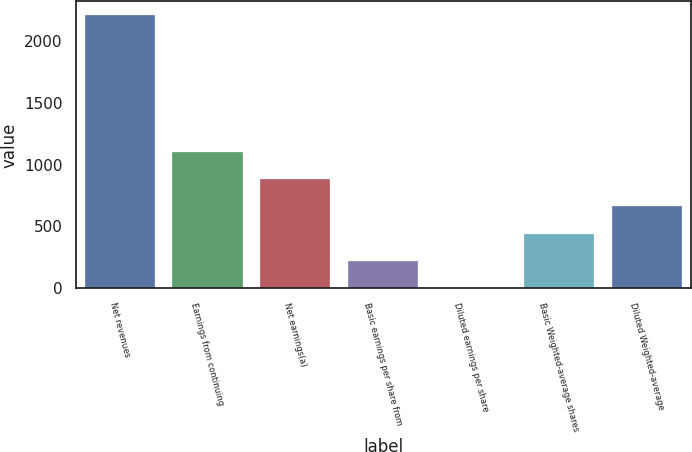Convert chart. <chart><loc_0><loc_0><loc_500><loc_500><bar_chart><fcel>Net revenues<fcel>Earnings from continuing<fcel>Net earnings(a)<fcel>Basic earnings per share from<fcel>Diluted earnings per share<fcel>Basic Weighted-average shares<fcel>Diluted Weighted-average<nl><fcel>2207.5<fcel>1104.41<fcel>883.8<fcel>221.97<fcel>1.36<fcel>442.58<fcel>663.19<nl></chart> 